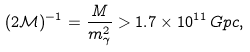<formula> <loc_0><loc_0><loc_500><loc_500>( 2 \mathcal { M } ) ^ { - 1 } = \frac { M } { m _ { \gamma } ^ { 2 } } > 1 . 7 \times 1 0 ^ { 1 1 } \, G p c ,</formula> 